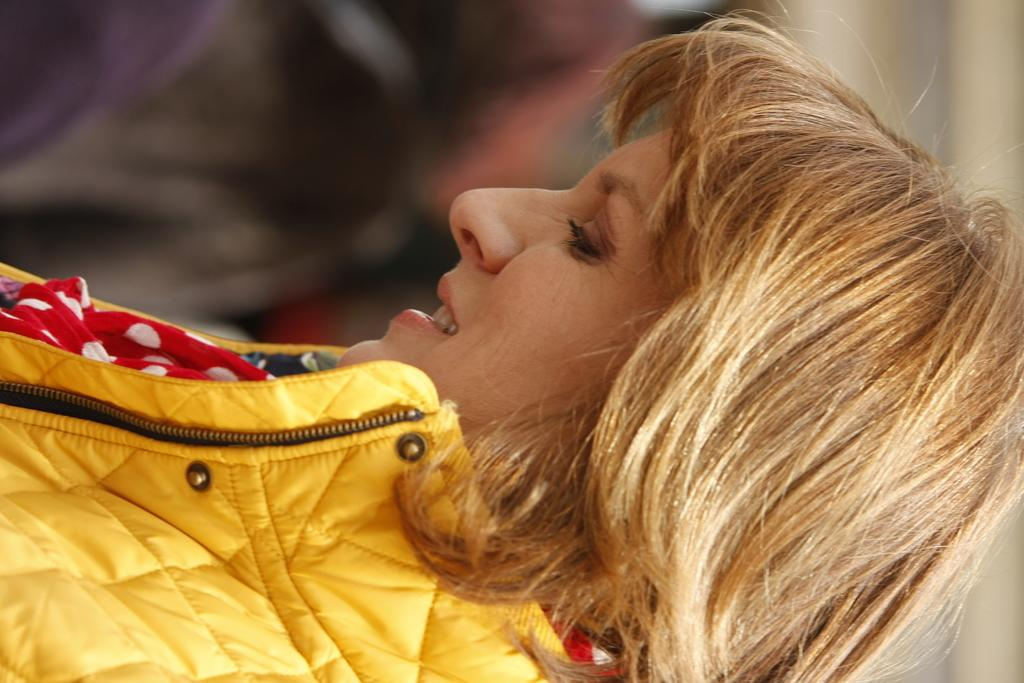What is the main subject of the image? The main subject of the image is a woman. What is the woman wearing in the image? The woman is wearing a yellow jacket in the image. What type of rhythm can be heard coming from the hill in the image? There is no hill or rhythm present in the image; it features a woman wearing a yellow jacket. 